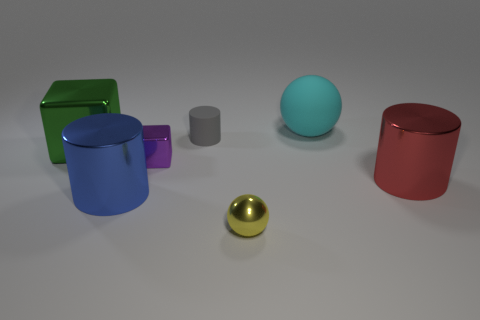Add 1 green cubes. How many objects exist? 8 Subtract all cylinders. How many objects are left? 4 Add 6 yellow shiny things. How many yellow shiny things are left? 7 Add 6 big cyan rubber blocks. How many big cyan rubber blocks exist? 6 Subtract 0 red cubes. How many objects are left? 7 Subtract all tiny metallic spheres. Subtract all large rubber cylinders. How many objects are left? 6 